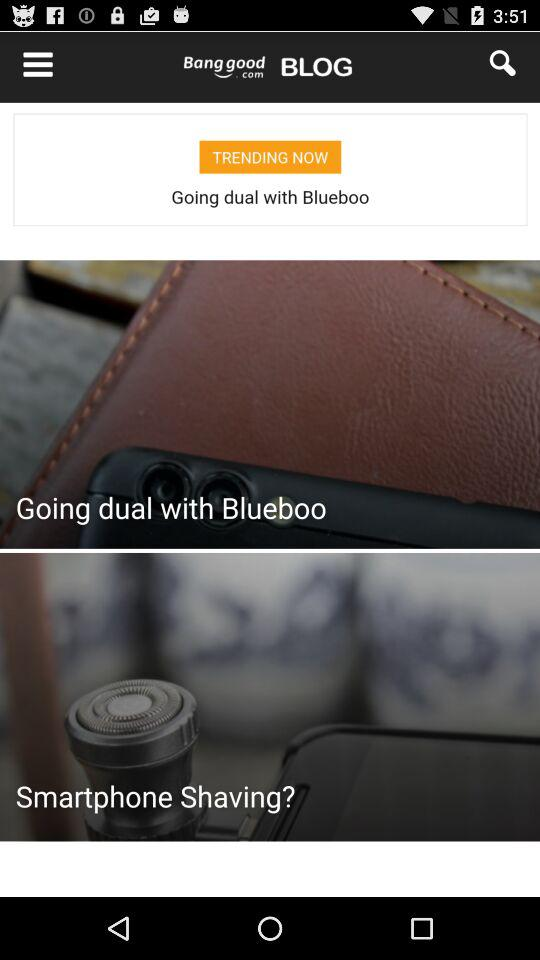What is the price of the product in dollars?
Answer the question using a single word or phrase. US$20.99 